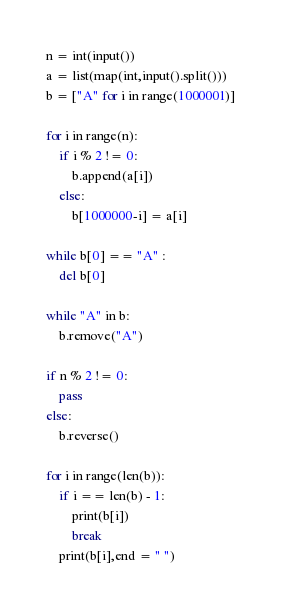Convert code to text. <code><loc_0><loc_0><loc_500><loc_500><_Python_>
n = int(input())
a = list(map(int,input().split()))
b = ["A" for i in range(1000001)]

for i in range(n):
    if i % 2 != 0:
        b.append(a[i])
    else:
        b[1000000-i] = a[i]

while b[0] == "A" :
    del b[0]

while "A" in b:
    b.remove("A")

if n % 2 != 0:
    pass
else:
    b.reverse()

for i in range(len(b)):
    if i == len(b) - 1:
        print(b[i])
        break
    print(b[i],end = " ")</code> 